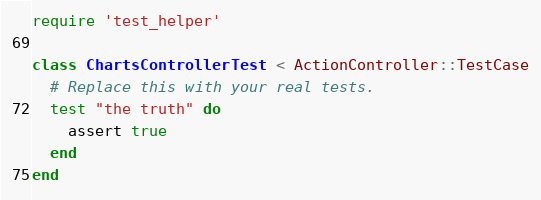<code> <loc_0><loc_0><loc_500><loc_500><_Ruby_>require 'test_helper'

class ChartsControllerTest < ActionController::TestCase
  # Replace this with your real tests.
  test "the truth" do
    assert true
  end
end
</code> 